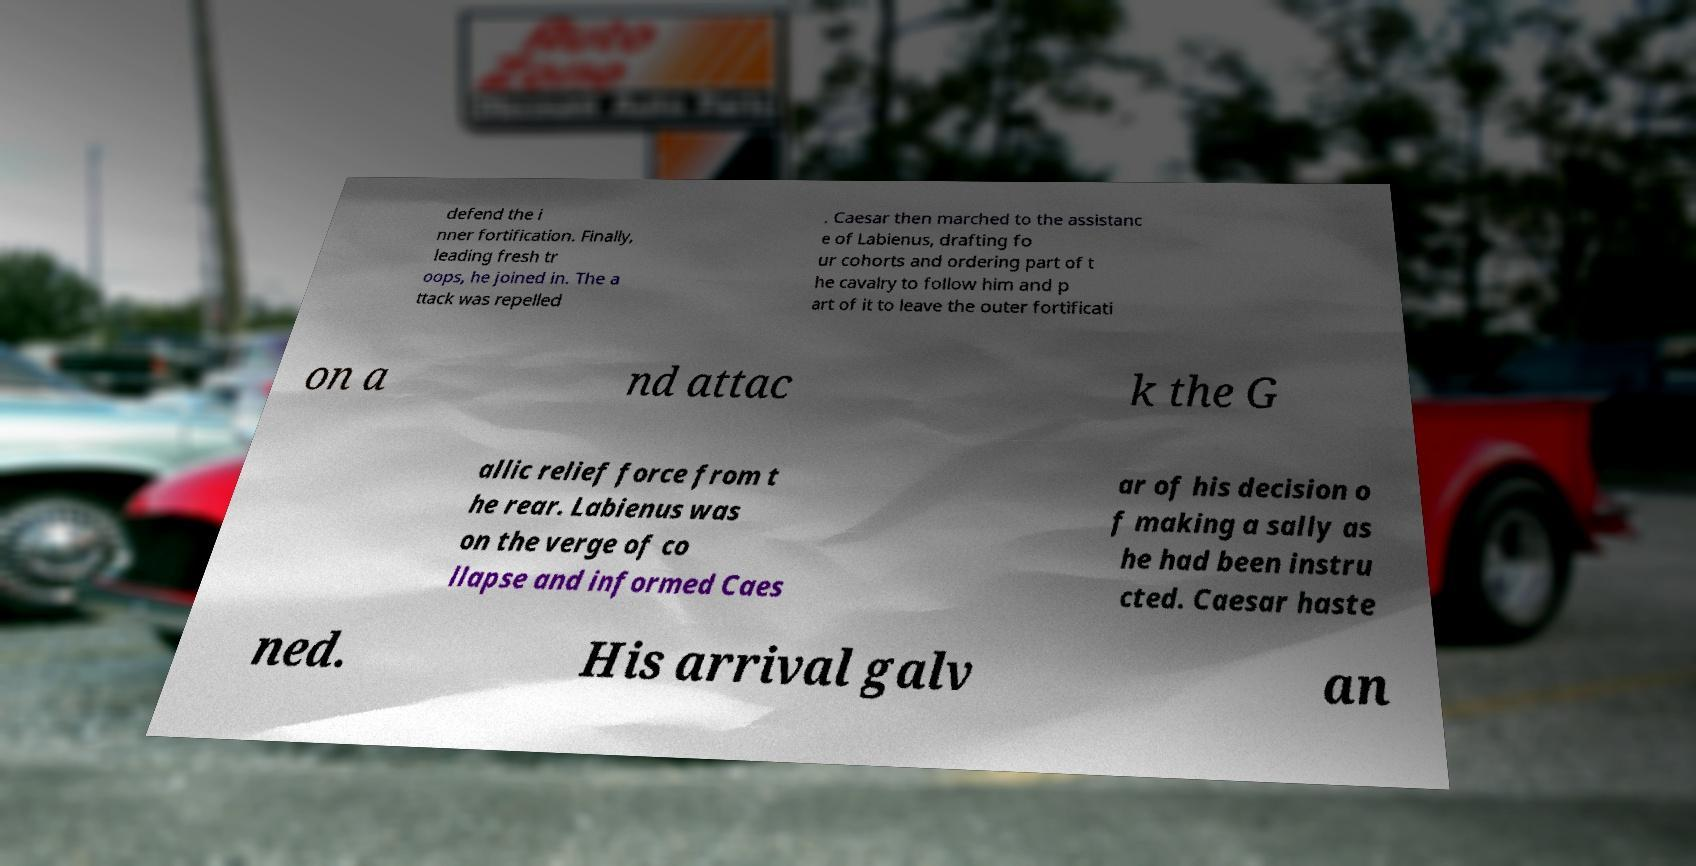Please identify and transcribe the text found in this image. defend the i nner fortification. Finally, leading fresh tr oops, he joined in. The a ttack was repelled . Caesar then marched to the assistanc e of Labienus, drafting fo ur cohorts and ordering part of t he cavalry to follow him and p art of it to leave the outer fortificati on a nd attac k the G allic relief force from t he rear. Labienus was on the verge of co llapse and informed Caes ar of his decision o f making a sally as he had been instru cted. Caesar haste ned. His arrival galv an 